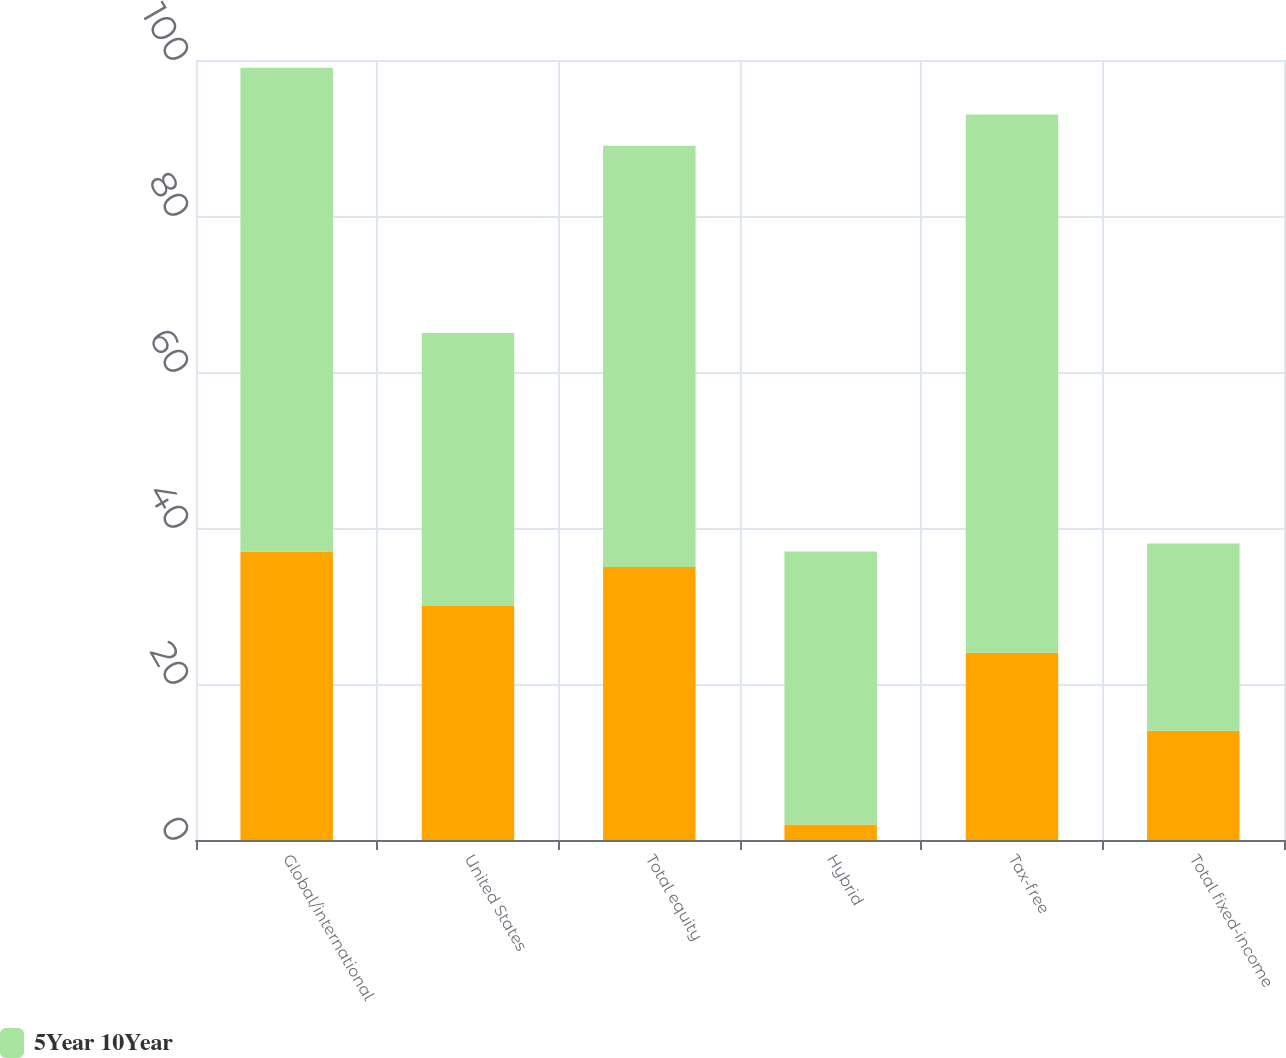Convert chart. <chart><loc_0><loc_0><loc_500><loc_500><stacked_bar_chart><ecel><fcel>Global/international<fcel>United States<fcel>Total equity<fcel>Hybrid<fcel>Tax-free<fcel>Total fixed-income<nl><fcel>nan<fcel>37<fcel>30<fcel>35<fcel>2<fcel>24<fcel>14<nl><fcel>5Year 10Year<fcel>62<fcel>35<fcel>54<fcel>35<fcel>69<fcel>24<nl></chart> 